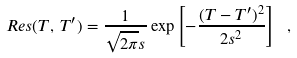Convert formula to latex. <formula><loc_0><loc_0><loc_500><loc_500>R e s ( T , \, T ^ { \prime } ) = \frac { 1 } { \sqrt { 2 \pi } s } \exp \left [ { - \frac { ( T - T ^ { \prime } ) ^ { 2 } } { 2 s ^ { 2 } } } \right ] \ ,</formula> 